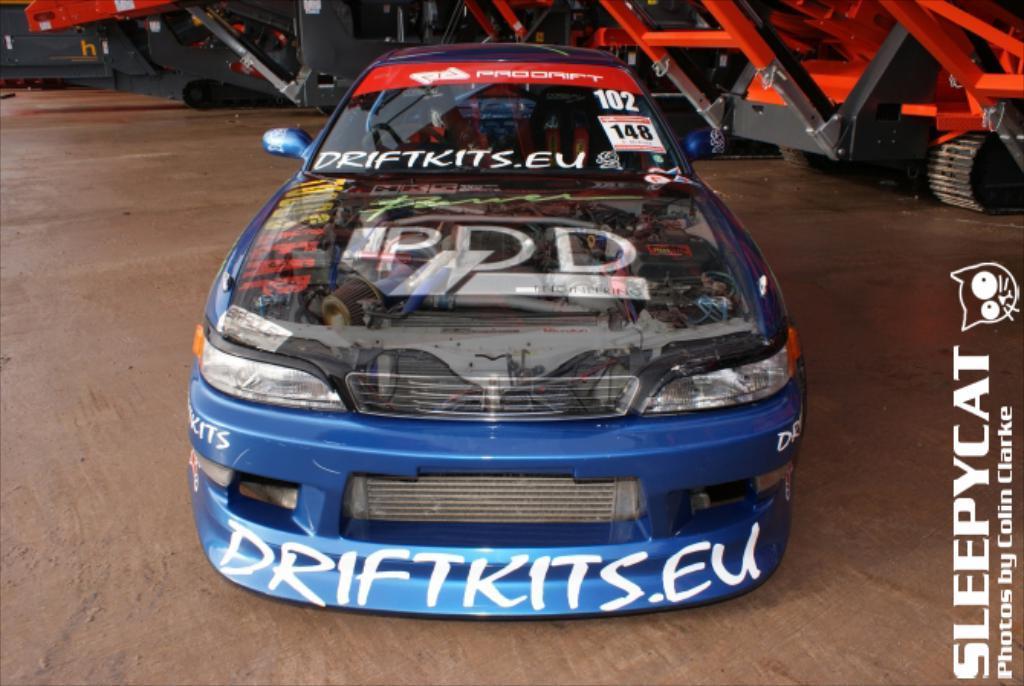In one or two sentences, can you explain what this image depicts? In this image, we can see some vehicles. We can also see the ground. We can see some text on the right. 